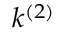<formula> <loc_0><loc_0><loc_500><loc_500>k ^ { ( 2 ) }</formula> 